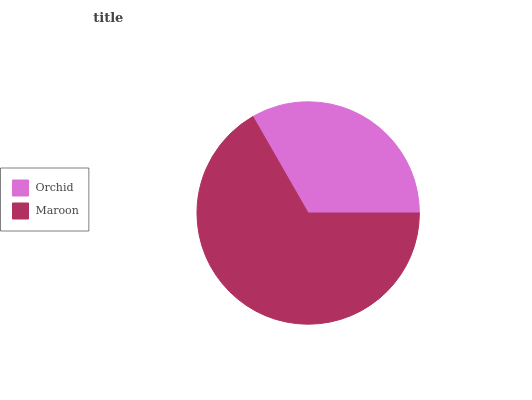Is Orchid the minimum?
Answer yes or no. Yes. Is Maroon the maximum?
Answer yes or no. Yes. Is Maroon the minimum?
Answer yes or no. No. Is Maroon greater than Orchid?
Answer yes or no. Yes. Is Orchid less than Maroon?
Answer yes or no. Yes. Is Orchid greater than Maroon?
Answer yes or no. No. Is Maroon less than Orchid?
Answer yes or no. No. Is Maroon the high median?
Answer yes or no. Yes. Is Orchid the low median?
Answer yes or no. Yes. Is Orchid the high median?
Answer yes or no. No. Is Maroon the low median?
Answer yes or no. No. 